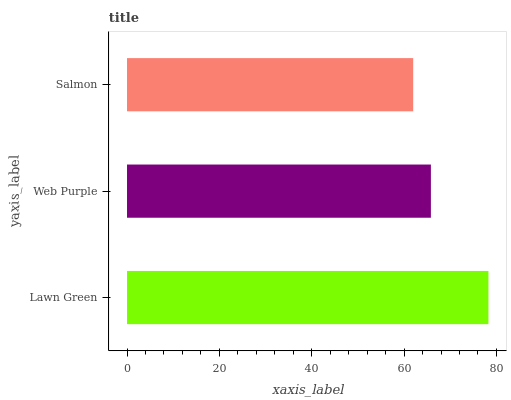Is Salmon the minimum?
Answer yes or no. Yes. Is Lawn Green the maximum?
Answer yes or no. Yes. Is Web Purple the minimum?
Answer yes or no. No. Is Web Purple the maximum?
Answer yes or no. No. Is Lawn Green greater than Web Purple?
Answer yes or no. Yes. Is Web Purple less than Lawn Green?
Answer yes or no. Yes. Is Web Purple greater than Lawn Green?
Answer yes or no. No. Is Lawn Green less than Web Purple?
Answer yes or no. No. Is Web Purple the high median?
Answer yes or no. Yes. Is Web Purple the low median?
Answer yes or no. Yes. Is Lawn Green the high median?
Answer yes or no. No. Is Salmon the low median?
Answer yes or no. No. 